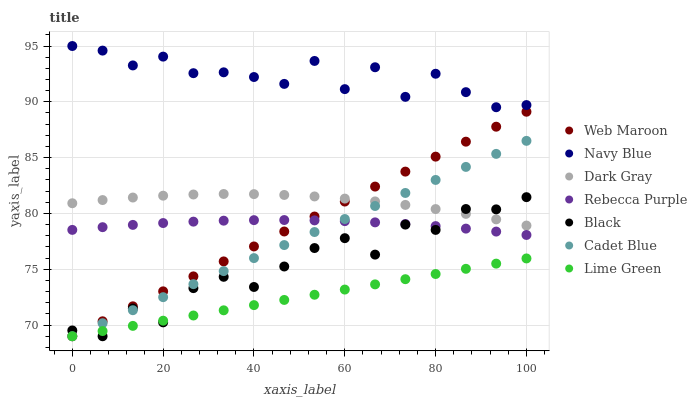Does Lime Green have the minimum area under the curve?
Answer yes or no. Yes. Does Navy Blue have the maximum area under the curve?
Answer yes or no. Yes. Does Web Maroon have the minimum area under the curve?
Answer yes or no. No. Does Web Maroon have the maximum area under the curve?
Answer yes or no. No. Is Cadet Blue the smoothest?
Answer yes or no. Yes. Is Navy Blue the roughest?
Answer yes or no. Yes. Is Web Maroon the smoothest?
Answer yes or no. No. Is Web Maroon the roughest?
Answer yes or no. No. Does Cadet Blue have the lowest value?
Answer yes or no. Yes. Does Navy Blue have the lowest value?
Answer yes or no. No. Does Navy Blue have the highest value?
Answer yes or no. Yes. Does Web Maroon have the highest value?
Answer yes or no. No. Is Black less than Navy Blue?
Answer yes or no. Yes. Is Dark Gray greater than Lime Green?
Answer yes or no. Yes. Does Rebecca Purple intersect Black?
Answer yes or no. Yes. Is Rebecca Purple less than Black?
Answer yes or no. No. Is Rebecca Purple greater than Black?
Answer yes or no. No. Does Black intersect Navy Blue?
Answer yes or no. No. 